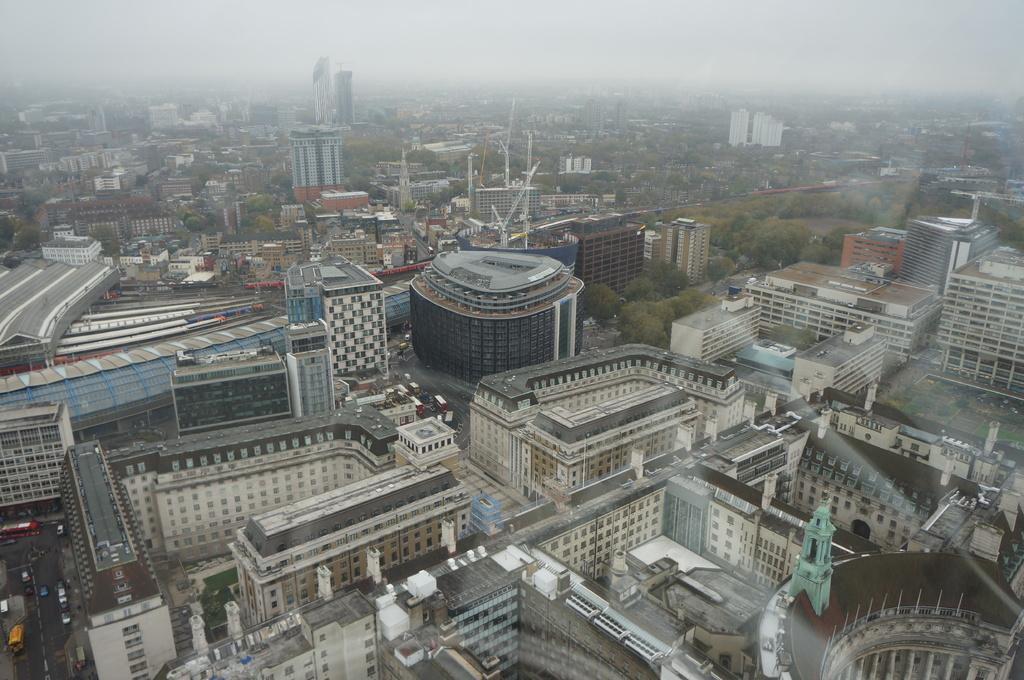What type of structures can be seen in the image? There are buildings in the image. What is located on the left side of the image? The road is on the left side of the image. What else can be seen on the road? There are vehicles on the road in the image. What type of natural elements are present in the image? There are trees in the image. What color is the hair of the brick in the image? There is no hair or brick present in the image. 